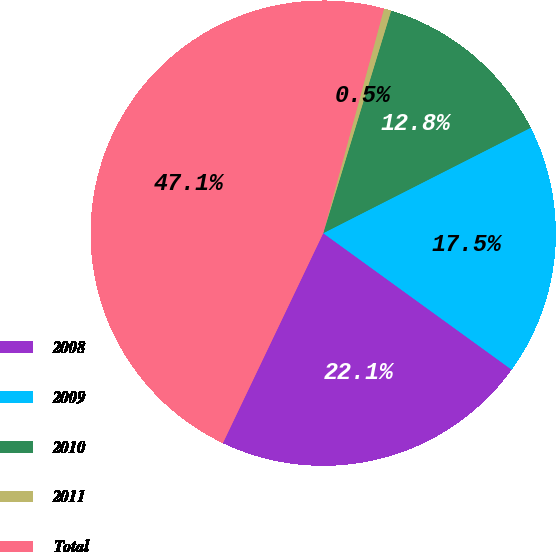<chart> <loc_0><loc_0><loc_500><loc_500><pie_chart><fcel>2008<fcel>2009<fcel>2010<fcel>2011<fcel>Total<nl><fcel>22.12%<fcel>17.46%<fcel>12.8%<fcel>0.51%<fcel>47.11%<nl></chart> 